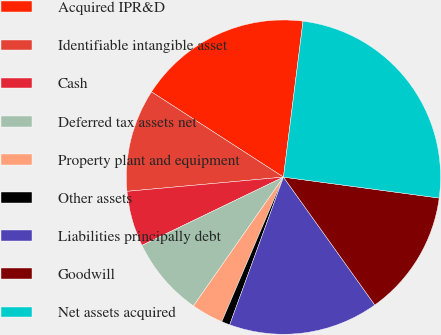<chart> <loc_0><loc_0><loc_500><loc_500><pie_chart><fcel>Acquired IPR&D<fcel>Identifiable intangible asset<fcel>Cash<fcel>Deferred tax assets net<fcel>Property plant and equipment<fcel>Other assets<fcel>Liabilities principally debt<fcel>Goodwill<fcel>Net assets acquired<nl><fcel>17.86%<fcel>10.57%<fcel>5.71%<fcel>8.14%<fcel>3.29%<fcel>0.86%<fcel>15.43%<fcel>13.0%<fcel>25.14%<nl></chart> 